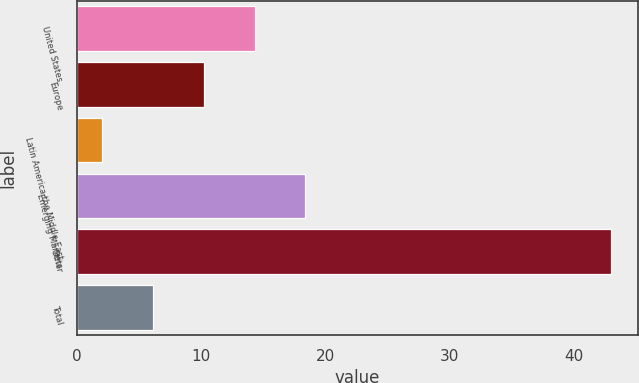<chart> <loc_0><loc_0><loc_500><loc_500><bar_chart><fcel>United States<fcel>Europe<fcel>Latin America the Middle East<fcel>Emerging Markets<fcel>Other<fcel>Total<nl><fcel>14.3<fcel>10.2<fcel>2<fcel>18.4<fcel>43<fcel>6.1<nl></chart> 